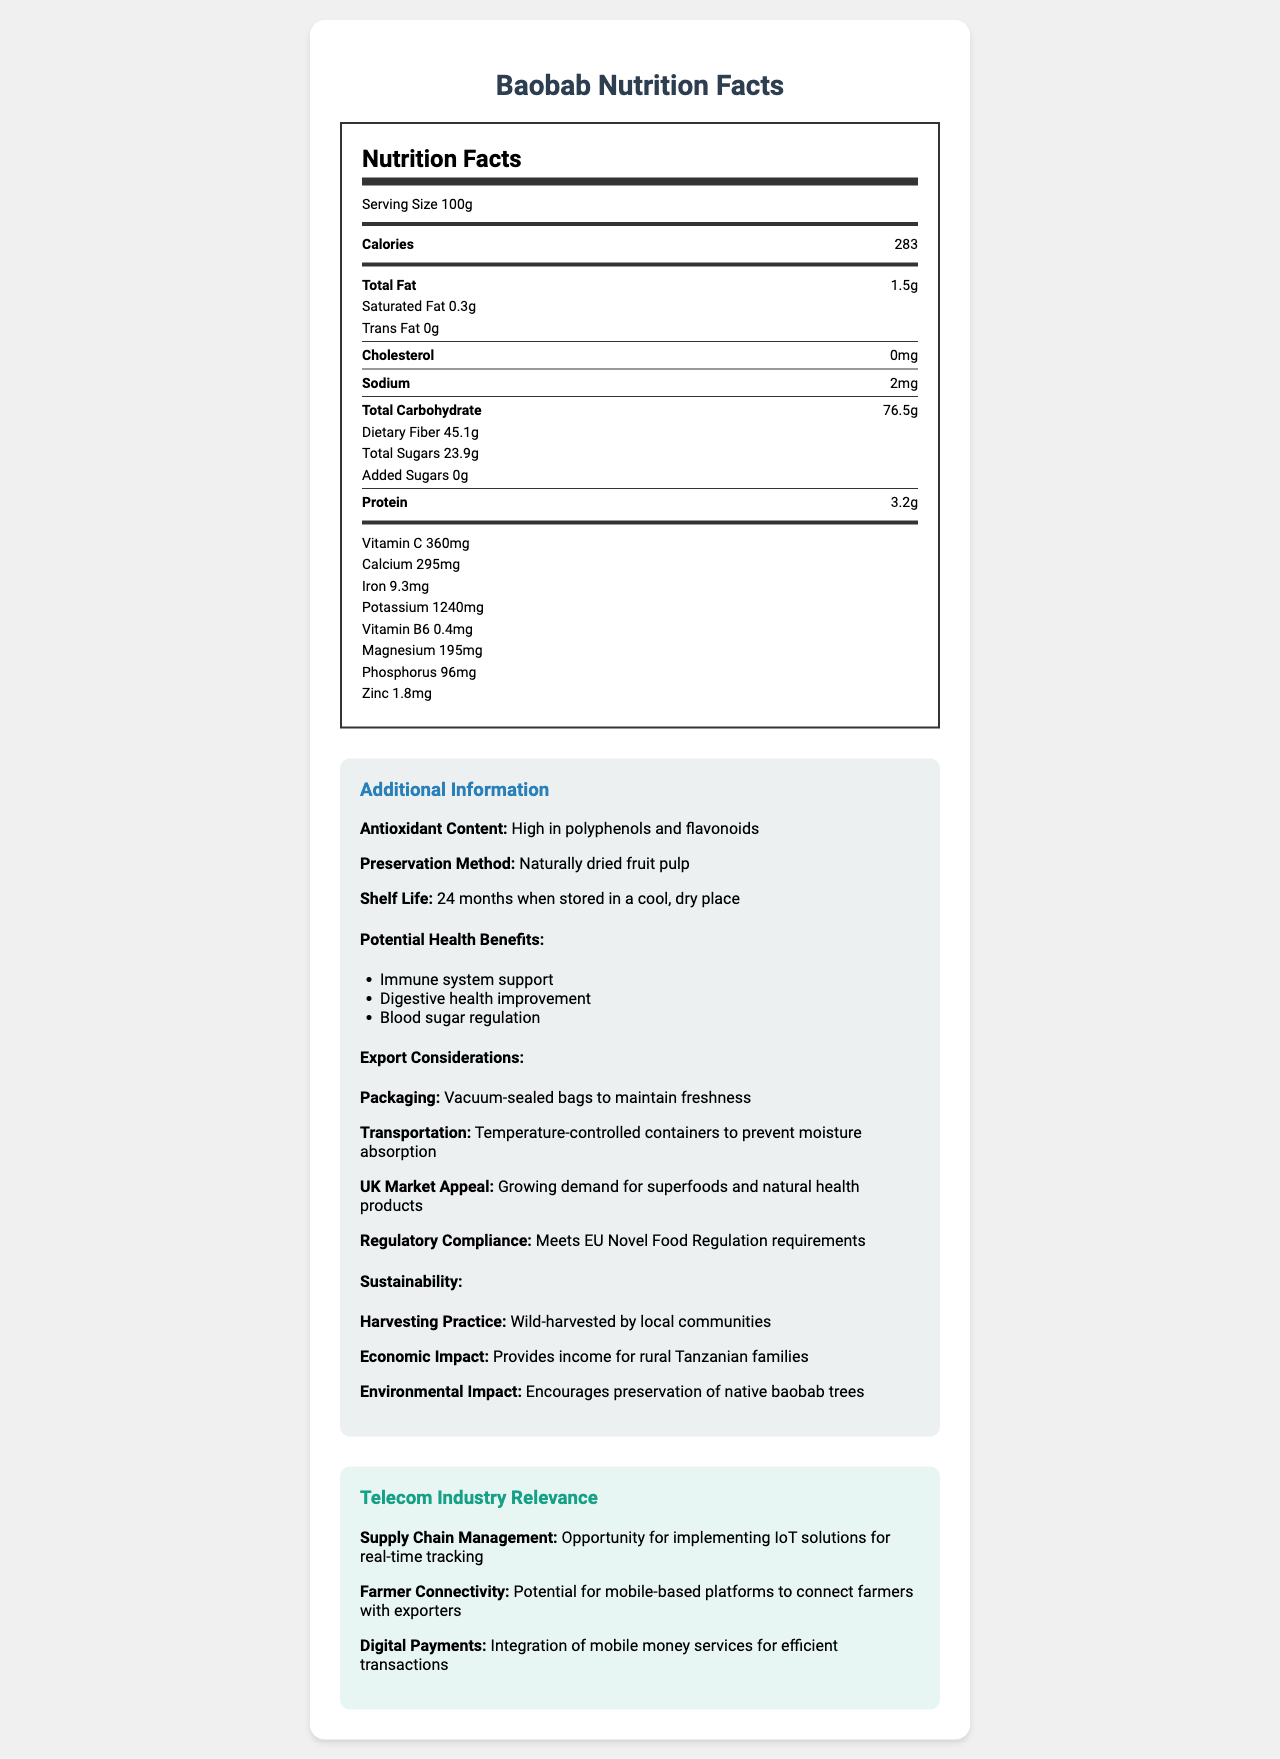what is the serving size for Baobab fruit? The document states that the serving size for Baobab fruit is 100g.
Answer: 100g how many calories are in a serving of Baobab fruit? The document lists 283 calories for a 100g serving of Baobab fruit.
Answer: 283 what is the total carbohydrate content in a 100g serving of Baobab fruit? According to the document, a 100g serving of Baobab fruit contains 76.5g of total carbohydrates.
Answer: 76.5g how much dietary fiber is in a 100g serving of Baobab fruit? The document indicates that there are 45.1g of dietary fiber in a 100g serving of Baobab fruit.
Answer: 45.1g what is the vitamin C content in a 100g serving of Baobab fruit? The document specifies that a 100g serving of Baobab fruit contains 360mg of vitamin C.
Answer: 360mg which method is used to preserve Baobab fruit? A. Freezing B. Canning C. Naturally drying The document states that the preservation method for Baobab fruit is "naturally dried fruit pulp."
Answer: C what is the shelf life of Baobab fruit when stored properly? A. 6 months B. 12 months C. 24 months The document mentions that the shelf life of Baobab fruit is 24 months when stored in a cool, dry place.
Answer: C does Baobab fruit meet the EU Novel Food Regulation requirements? The additional information section in the document indicates that Baobab fruit meets EU Novel Food Regulation requirements.
Answer: Yes describe the main idea of the document. The document outlines the nutritional information of Baobab fruit, emphasizing its high content of dietary fiber, vitamin C, and other nutrients. It includes additional details on health benefits, shelf life, export packaging, transportation requirements, as well as its compliance with regulatory standards and its environmental and economic impact. The relevance to the telecom industry is also explored, mentioning the potential for supply chain management, farmer connectivity, and digital payments.
Answer: The document provides a detailed nutritional analysis of Baobab fruit, highlighting its high nutrient content, potential health benefits, preservation methods, and export considerations specific to the UK market. It also discusses the fruit's sustainability and relevance to the telecom industry. what is the economic impact of harvesting Baobab fruit on local Tanzanian communities? The document states that wild-harvesting Baobab fruit by local communities provides income for rural Tanzanian families.
Answer: Provides income for rural Tanzanian families what percentage of Baobab fruit's total carbohydrate content is dietary fiber? The document lists 76.5g of total carbohydrates and 45.1g of dietary fiber. The percentage can be calculated as (45.1/76.5) * 100 which is approximately 59%.
Answer: Approximately 59% what is the total fat content in a 100g serving of Baobab fruit? The document lists that a 100g serving of Baobab fruit contains 1.5g of total fat.
Answer: 1.5g which nutrient in Baobab fruit aids in immune system support? The document states that one of the potential health benefits of Baobab fruit is immune system support, which is typically associated with high vitamin C content.
Answer: Vitamin C what are the steps needed to maintain the freshness of Baobab fruit during export? The export considerations section of the document mentions using vacuum-sealed bags for packaging and temperature-controlled containers for transportation to maintain freshness.
Answer: Vacuum-sealed packaging and temperature-controlled containers what aspects of the Baobab fruit's supply chain could IoT solutions address? The telecom industry relevance section of the document suggests that IoT solutions could be implemented for real-time tracking in the supply chain management of Baobab fruit.
Answer: Real-time tracking what is the harvesting practice for Baobab fruit in Tanzania? The document mentions that Baobab fruit is wild-harvested by local communities in Tanzania.
Answer: Wild-harvested by local communities how can farmers in Tanzania improve their connectivity with exporters for Baobab fruit? The telecom industry relevance section suggests that there is potential for mobile-based platforms to connect farmers with exporters, thereby improving connectivity.
Answer: Potential for mobile-based platforms is there any information on the vitamin D content of Baobab fruit? The document does not provide any information on the vitamin D content of Baobab fruit.
Answer: Cannot be determined 